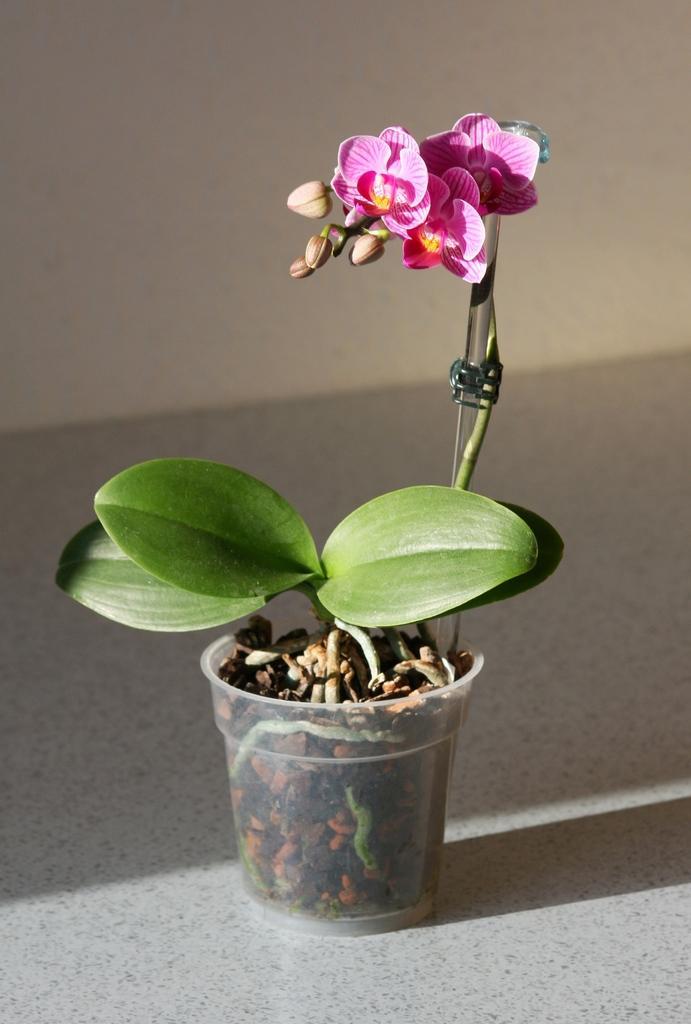Could you give a brief overview of what you see in this image? In this image in the center there is one flower pot plant and some flowers, at the bottom there is a floor and in the background there is a wall. 